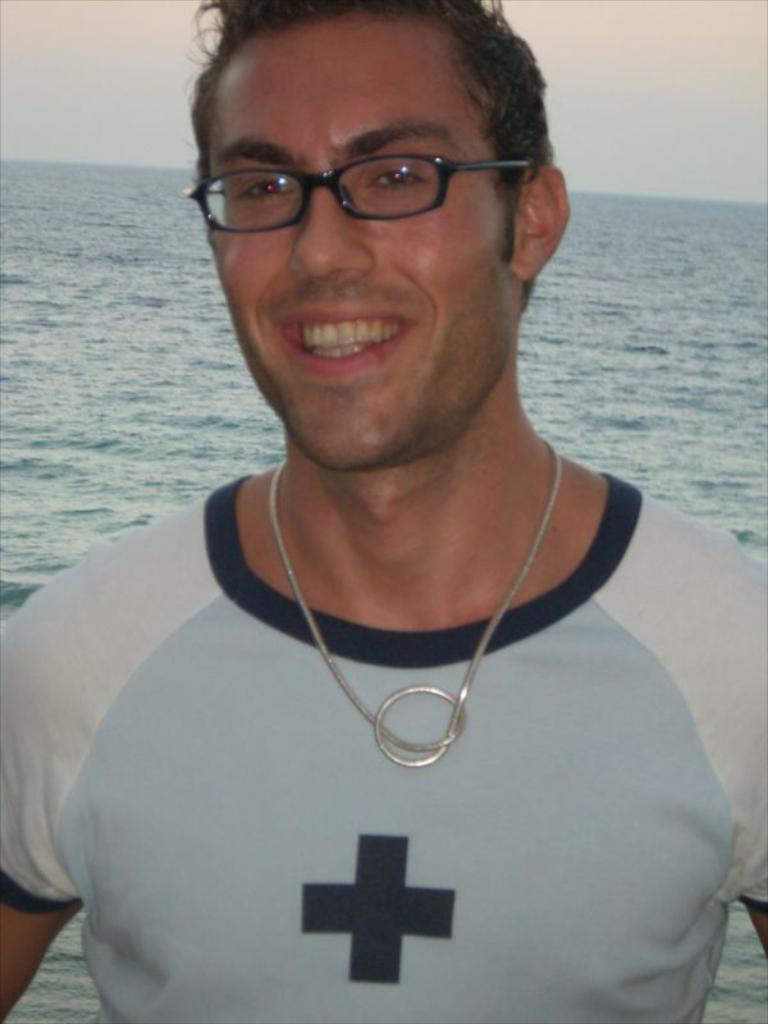Who or what is present in the image? There is a person in the image. What is the person doing or expressing? The person is smiling. What can be seen in the background of the image? There is water visible in the background of the image. How many ants are crawling on the person's face in the image? There are no ants present in the image. What type of sack is the person carrying in the image? There is no sack present in the image. 